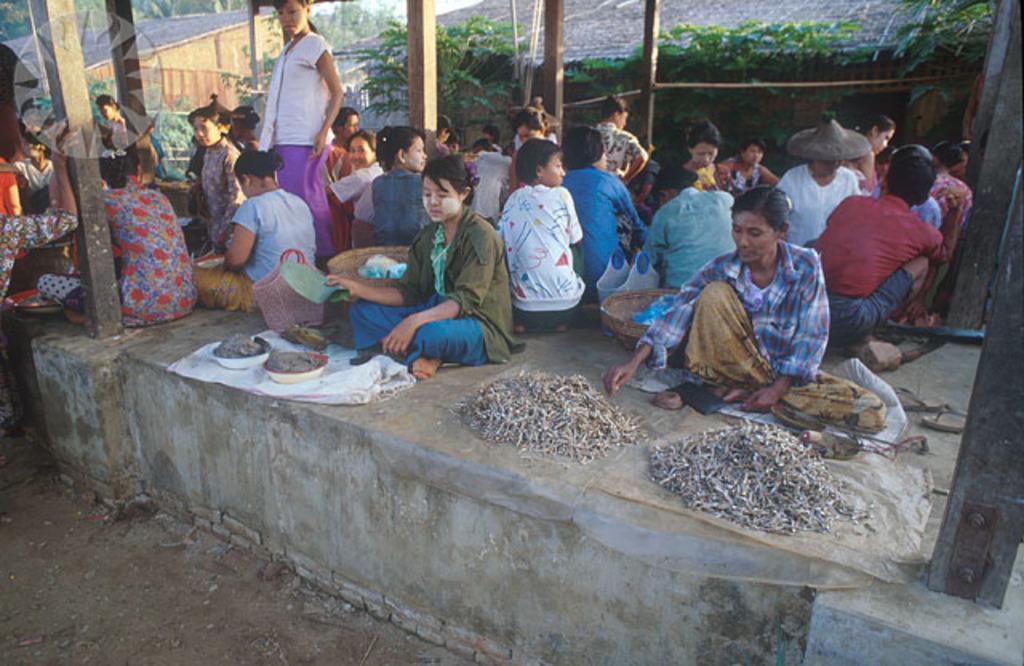Could you give a brief overview of what you see in this image? In this picture we can see a group of people sitting on the floor, baskets, bowls, footwear, pillars, wall, some objects and in the background we can see trees, sheds. 